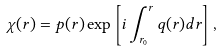<formula> <loc_0><loc_0><loc_500><loc_500>\chi ( r ) = p ( r ) \exp \left [ i \int _ { r _ { 0 } } ^ { r } q ( r ) d r \right ] ,</formula> 